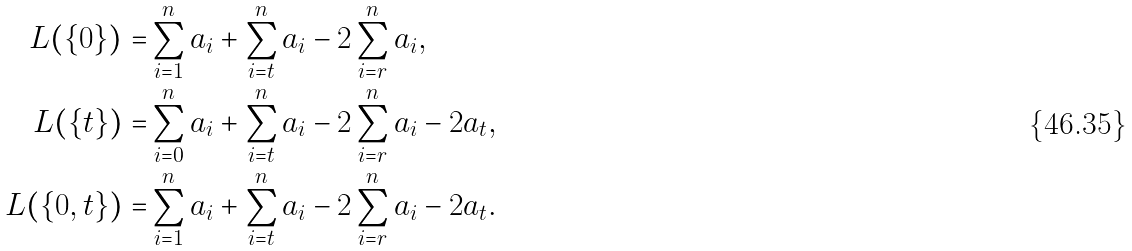Convert formula to latex. <formula><loc_0><loc_0><loc_500><loc_500>L ( \{ 0 \} ) = & \sum _ { i = 1 } ^ { n } a _ { i } + \sum _ { i = t } ^ { n } a _ { i } - 2 \sum _ { i = r } ^ { n } a _ { i } , \\ L ( \{ t \} ) = & \sum _ { i = 0 } ^ { n } a _ { i } + \sum _ { i = t } ^ { n } a _ { i } - 2 \sum _ { i = r } ^ { n } a _ { i } - 2 a _ { t } , \\ L ( \{ 0 , t \} ) = & \sum _ { i = 1 } ^ { n } a _ { i } + \sum _ { i = t } ^ { n } a _ { i } - 2 \sum _ { i = r } ^ { n } a _ { i } - 2 a _ { t } .</formula> 